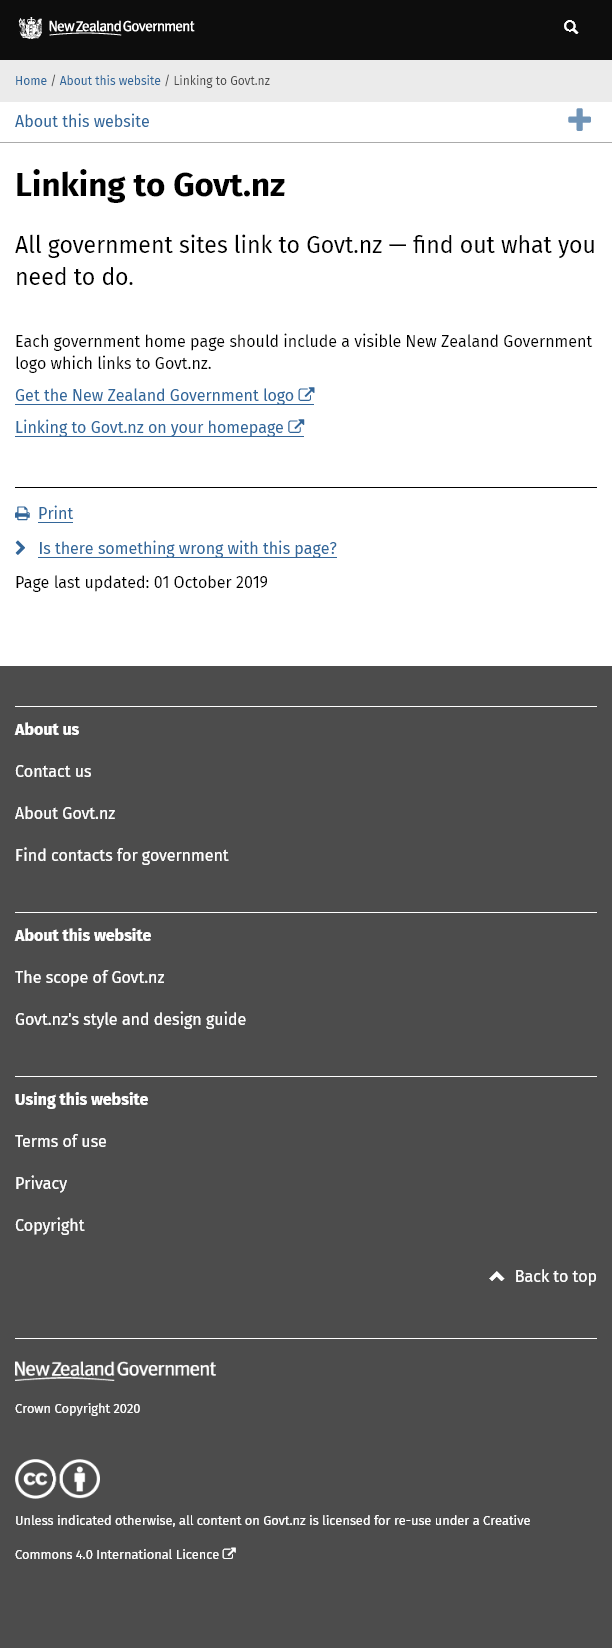Give some essential details in this illustration. The New Zealand Government logo can be obtained by clicking on the arrow link. It is essential for the home page of all government websites to prominently display the New Zealand Government logo. The website address that all government sites link to is govt.nz. 